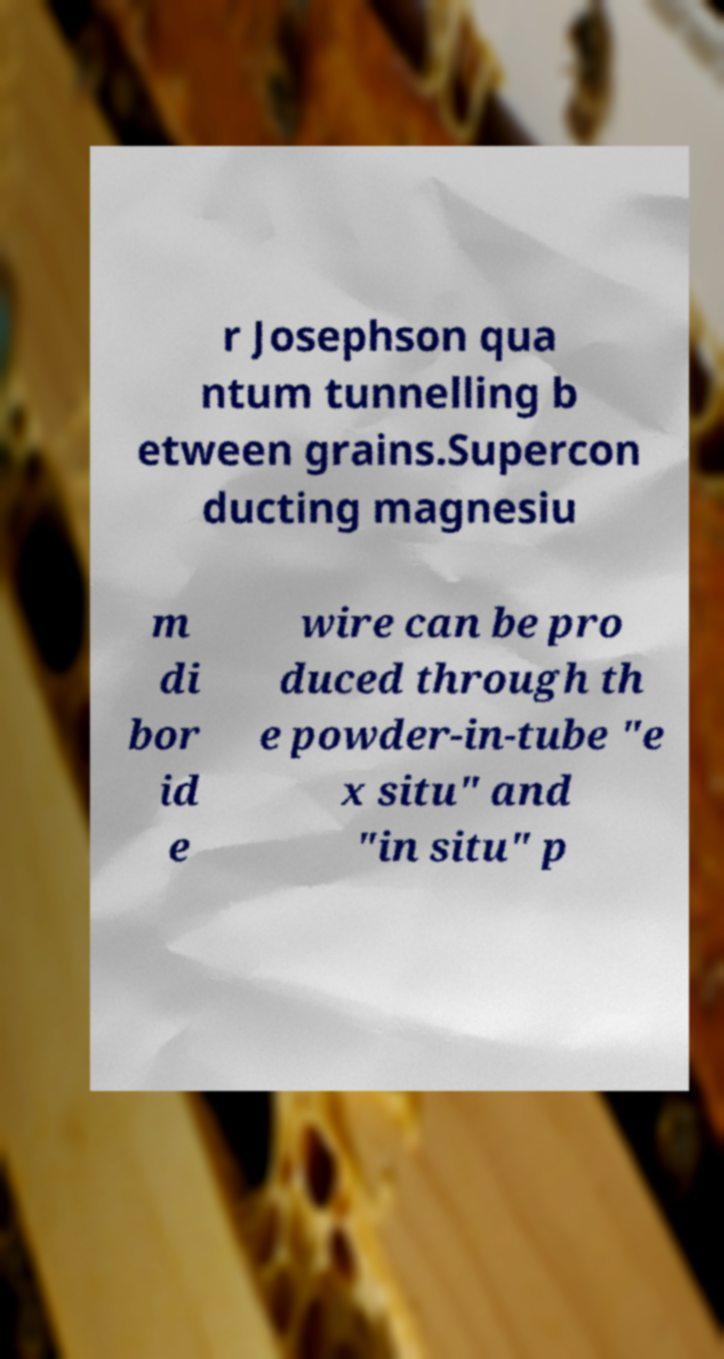What messages or text are displayed in this image? I need them in a readable, typed format. r Josephson qua ntum tunnelling b etween grains.Supercon ducting magnesiu m di bor id e wire can be pro duced through th e powder-in-tube "e x situ" and "in situ" p 